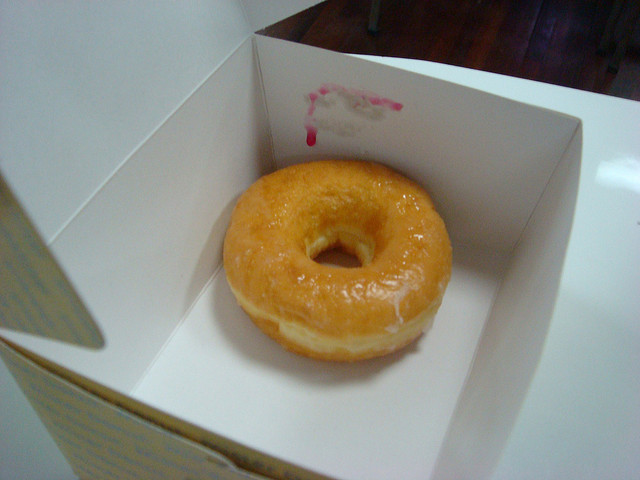Can you describe the box where the donut is placed? Certainly! The donut sits within a simple white cardboard box with one side partially open, allowing a glimpse of the donut inside. There's a small smudge of pink on the box's edge, possibly from a previous donut with pink icing. 